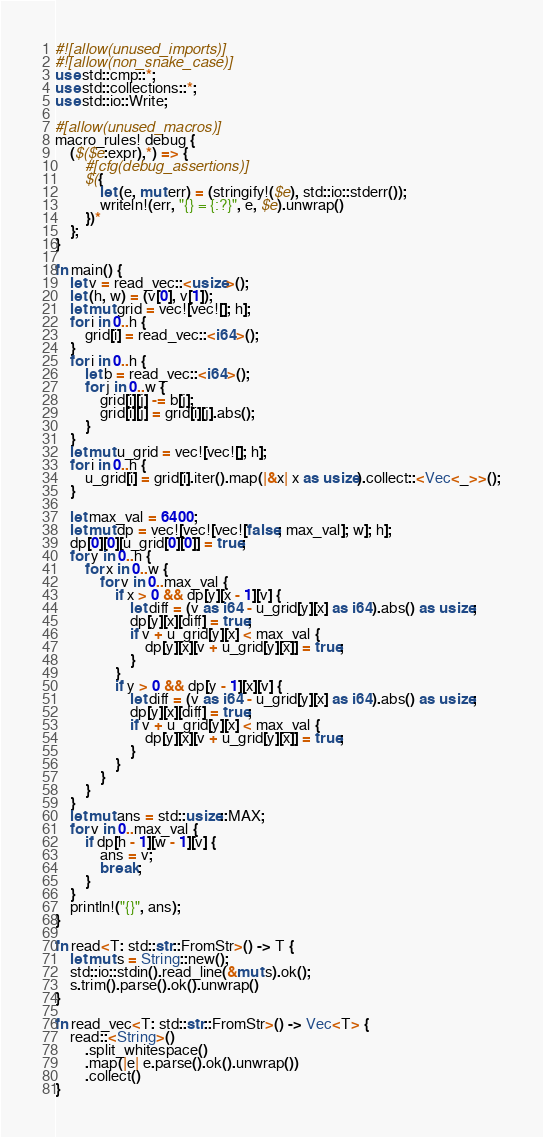<code> <loc_0><loc_0><loc_500><loc_500><_Rust_>#![allow(unused_imports)]
#![allow(non_snake_case)]
use std::cmp::*;
use std::collections::*;
use std::io::Write;

#[allow(unused_macros)]
macro_rules! debug {
    ($($e:expr),*) => {
        #[cfg(debug_assertions)]
        $({
            let (e, mut err) = (stringify!($e), std::io::stderr());
            writeln!(err, "{} = {:?}", e, $e).unwrap()
        })*
    };
}

fn main() {
    let v = read_vec::<usize>();
    let (h, w) = (v[0], v[1]);
    let mut grid = vec![vec![]; h];
    for i in 0..h {
        grid[i] = read_vec::<i64>();
    }
    for i in 0..h {
        let b = read_vec::<i64>();
        for j in 0..w {
            grid[i][j] -= b[j];
            grid[i][j] = grid[i][j].abs();
        }
    }
    let mut u_grid = vec![vec![]; h];
    for i in 0..h {
        u_grid[i] = grid[i].iter().map(|&x| x as usize).collect::<Vec<_>>();
    }

    let max_val = 6400;
    let mut dp = vec![vec![vec![false; max_val]; w]; h];
    dp[0][0][u_grid[0][0]] = true;
    for y in 0..h {
        for x in 0..w {
            for v in 0..max_val {
                if x > 0 && dp[y][x - 1][v] {
                    let diff = (v as i64 - u_grid[y][x] as i64).abs() as usize;
                    dp[y][x][diff] = true;
                    if v + u_grid[y][x] < max_val {
                        dp[y][x][v + u_grid[y][x]] = true;
                    }
                }
                if y > 0 && dp[y - 1][x][v] {
                    let diff = (v as i64 - u_grid[y][x] as i64).abs() as usize;
                    dp[y][x][diff] = true;
                    if v + u_grid[y][x] < max_val {
                        dp[y][x][v + u_grid[y][x]] = true;
                    }
                }
            }
        }
    }
    let mut ans = std::usize::MAX;
    for v in 0..max_val {
        if dp[h - 1][w - 1][v] {
            ans = v;
            break;
        }
    }
    println!("{}", ans);
}

fn read<T: std::str::FromStr>() -> T {
    let mut s = String::new();
    std::io::stdin().read_line(&mut s).ok();
    s.trim().parse().ok().unwrap()
}

fn read_vec<T: std::str::FromStr>() -> Vec<T> {
    read::<String>()
        .split_whitespace()
        .map(|e| e.parse().ok().unwrap())
        .collect()
}
</code> 